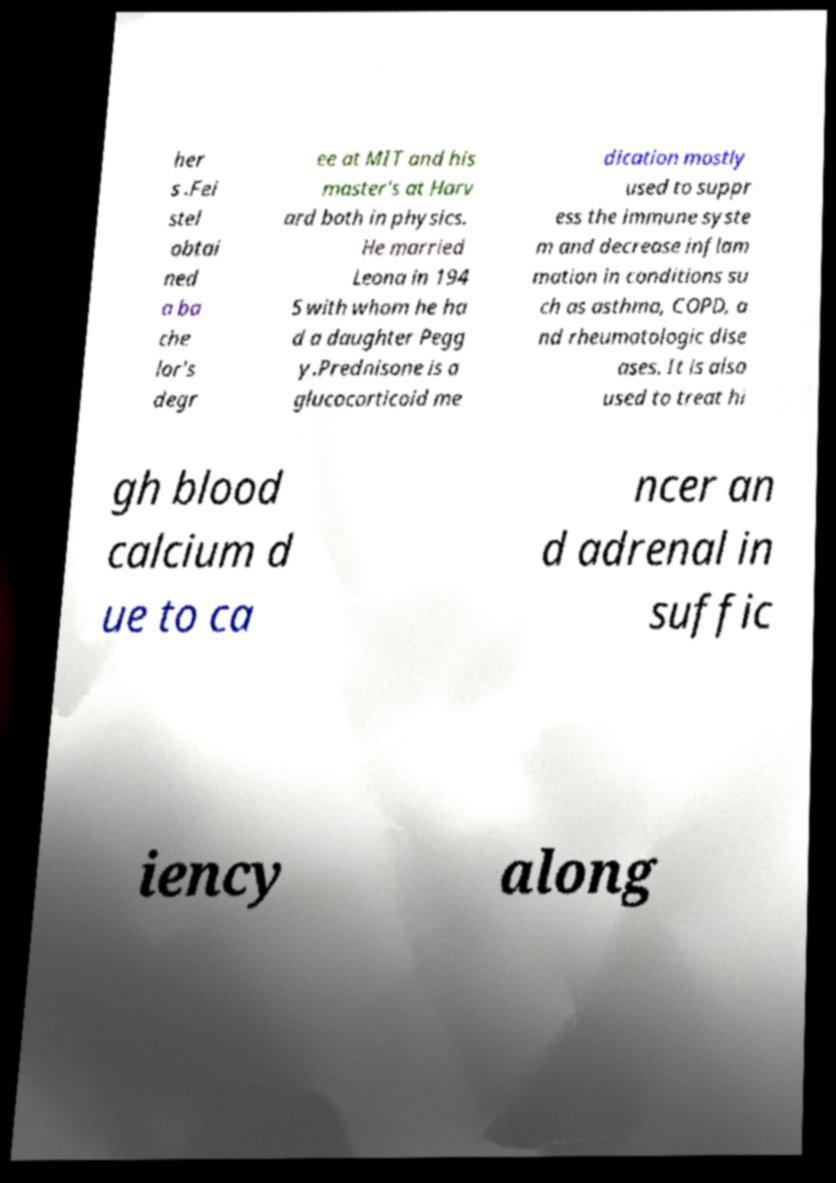For documentation purposes, I need the text within this image transcribed. Could you provide that? her s .Fei stel obtai ned a ba che lor's degr ee at MIT and his master's at Harv ard both in physics. He married Leona in 194 5 with whom he ha d a daughter Pegg y.Prednisone is a glucocorticoid me dication mostly used to suppr ess the immune syste m and decrease inflam mation in conditions su ch as asthma, COPD, a nd rheumatologic dise ases. It is also used to treat hi gh blood calcium d ue to ca ncer an d adrenal in suffic iency along 